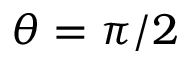Convert formula to latex. <formula><loc_0><loc_0><loc_500><loc_500>\theta = \pi / 2</formula> 